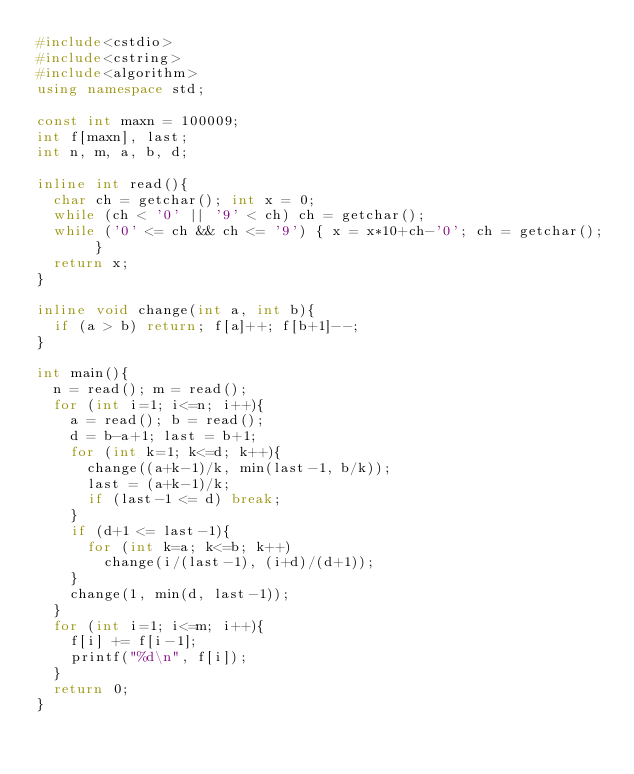Convert code to text. <code><loc_0><loc_0><loc_500><loc_500><_C++_>#include<cstdio>
#include<cstring>
#include<algorithm>
using namespace std;

const int maxn = 100009;
int f[maxn], last;
int n, m, a, b, d;

inline int read(){
	char ch = getchar(); int x = 0;
	while (ch < '0' || '9' < ch) ch = getchar();
	while ('0' <= ch && ch <= '9') { x = x*10+ch-'0'; ch = getchar(); }
	return x;
}

inline void change(int a, int b){
	if (a > b) return; f[a]++; f[b+1]--;
}

int main(){
	n = read(); m = read();
	for (int i=1; i<=n; i++){
		a = read(); b = read();
		d = b-a+1; last = b+1;
		for (int k=1; k<=d; k++){
			change((a+k-1)/k, min(last-1, b/k));
			last = (a+k-1)/k;
			if (last-1 <= d) break; 
		}
		if (d+1 <= last-1){
			for (int k=a; k<=b; k++)
				change(i/(last-1), (i+d)/(d+1));
		}
		change(1, min(d, last-1));
	}
	for (int i=1; i<=m; i++){
		f[i] += f[i-1];
		printf("%d\n", f[i]);
	}
	return 0;
}</code> 